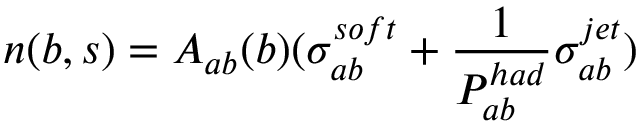Convert formula to latex. <formula><loc_0><loc_0><loc_500><loc_500>n ( b , s ) = A _ { a b } ( b ) ( \sigma _ { a b } ^ { s o f t } + { \frac { 1 } { P _ { a b } ^ { h a d } } } \sigma _ { a b } ^ { j e t } )</formula> 